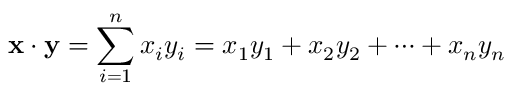<formula> <loc_0><loc_0><loc_500><loc_500>x \cdot y = \sum _ { i = 1 } ^ { n } x _ { i } y _ { i } = x _ { 1 } y _ { 1 } + x _ { 2 } y _ { 2 } + \cdots + x _ { n } y _ { n }</formula> 